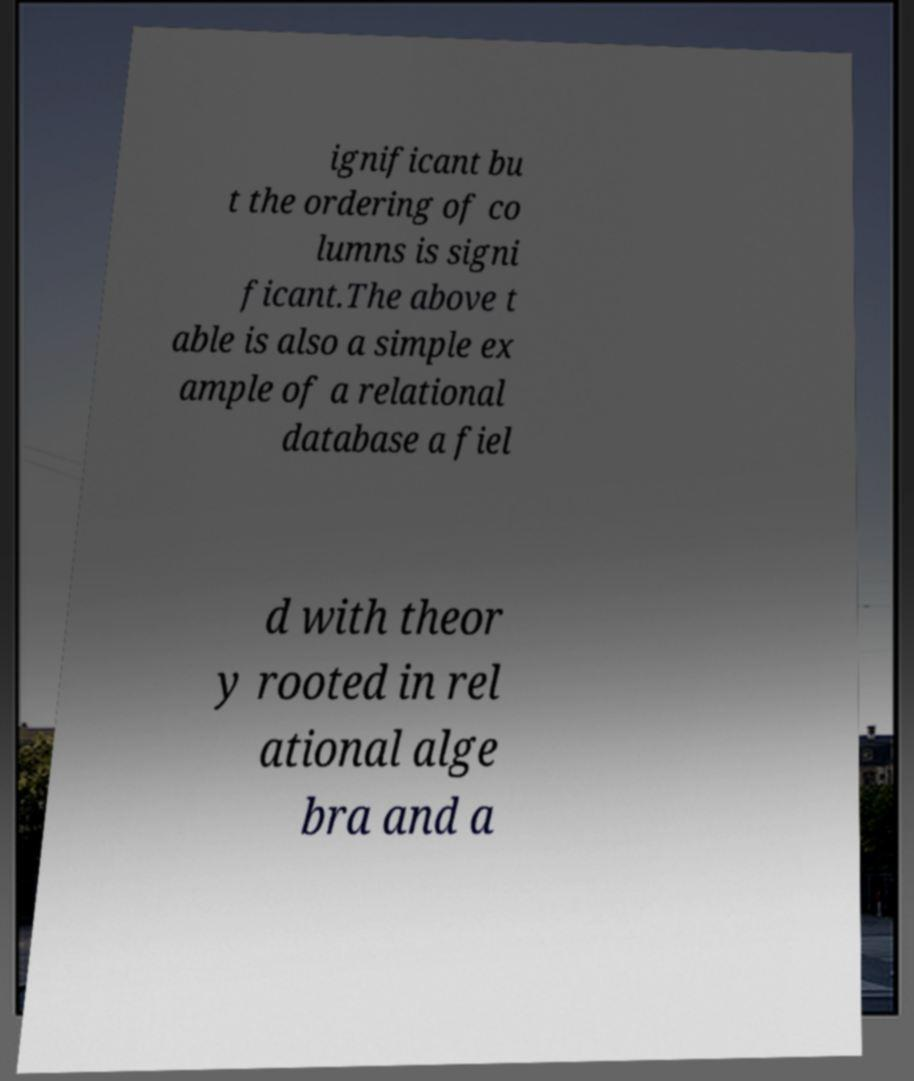Please identify and transcribe the text found in this image. ignificant bu t the ordering of co lumns is signi ficant.The above t able is also a simple ex ample of a relational database a fiel d with theor y rooted in rel ational alge bra and a 